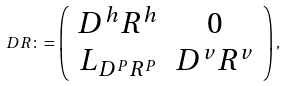<formula> <loc_0><loc_0><loc_500><loc_500>D R \colon = \left ( \begin{array} { c c } D ^ { h } R ^ { h } & 0 \\ L _ { D ^ { P } R ^ { P } } & D ^ { v } R ^ { v } \end{array} \right ) ,</formula> 